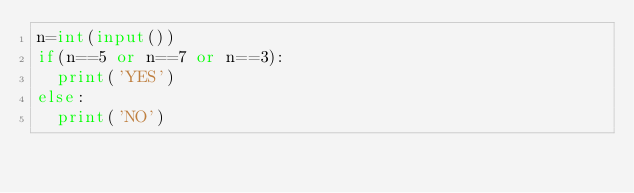<code> <loc_0><loc_0><loc_500><loc_500><_Python_>n=int(input())
if(n==5 or n==7 or n==3):
  print('YES')
else:
  print('NO')</code> 